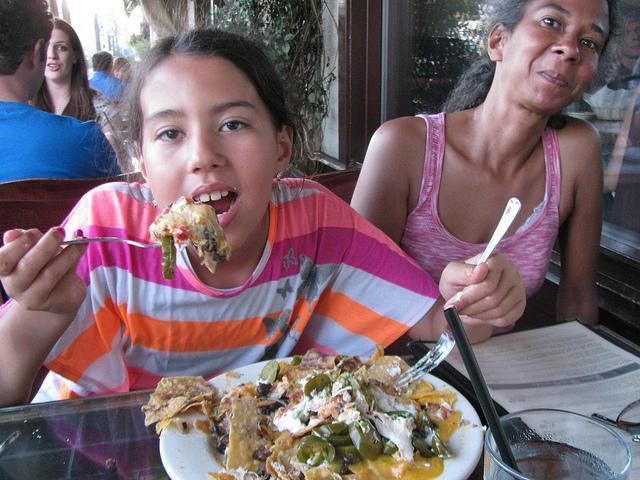How many people can you see?
Give a very brief answer. 4. How many dining tables can you see?
Give a very brief answer. 2. 